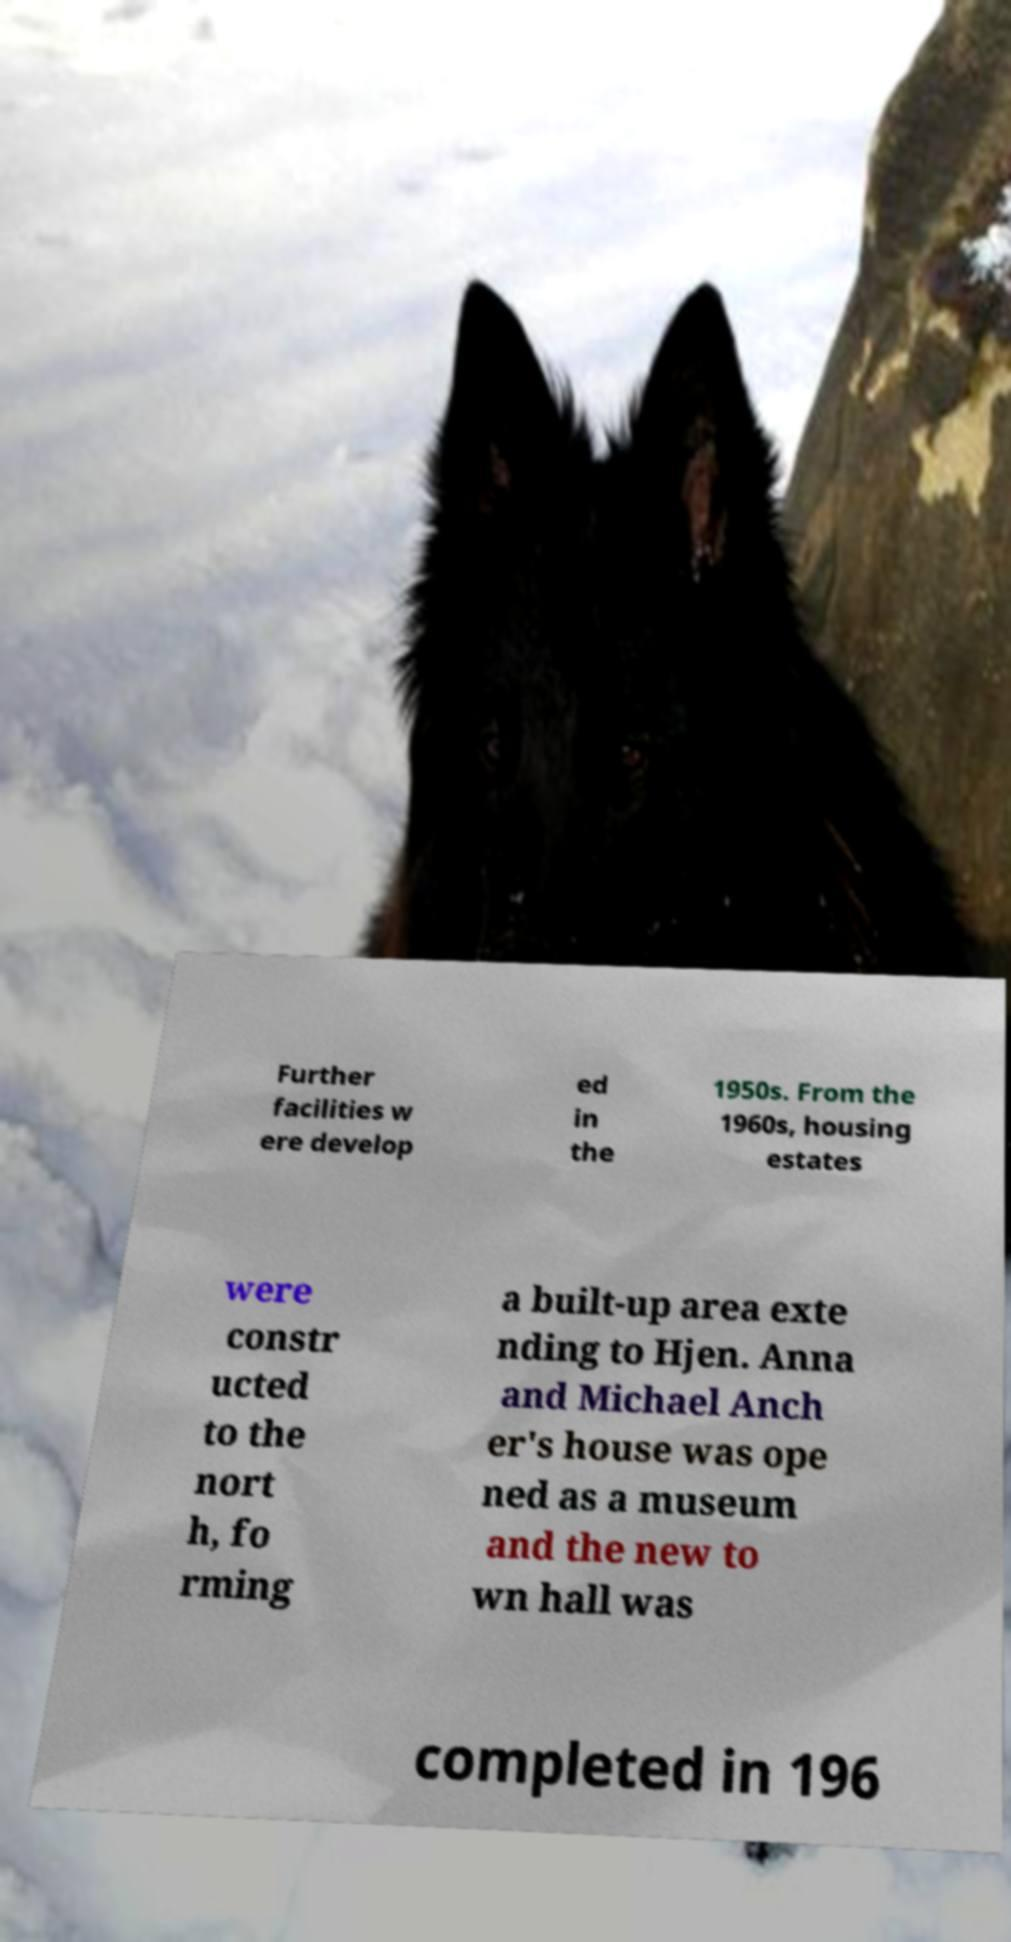Can you accurately transcribe the text from the provided image for me? Further facilities w ere develop ed in the 1950s. From the 1960s, housing estates were constr ucted to the nort h, fo rming a built-up area exte nding to Hjen. Anna and Michael Anch er's house was ope ned as a museum and the new to wn hall was completed in 196 